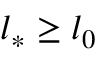<formula> <loc_0><loc_0><loc_500><loc_500>l _ { * } \geq l _ { 0 }</formula> 